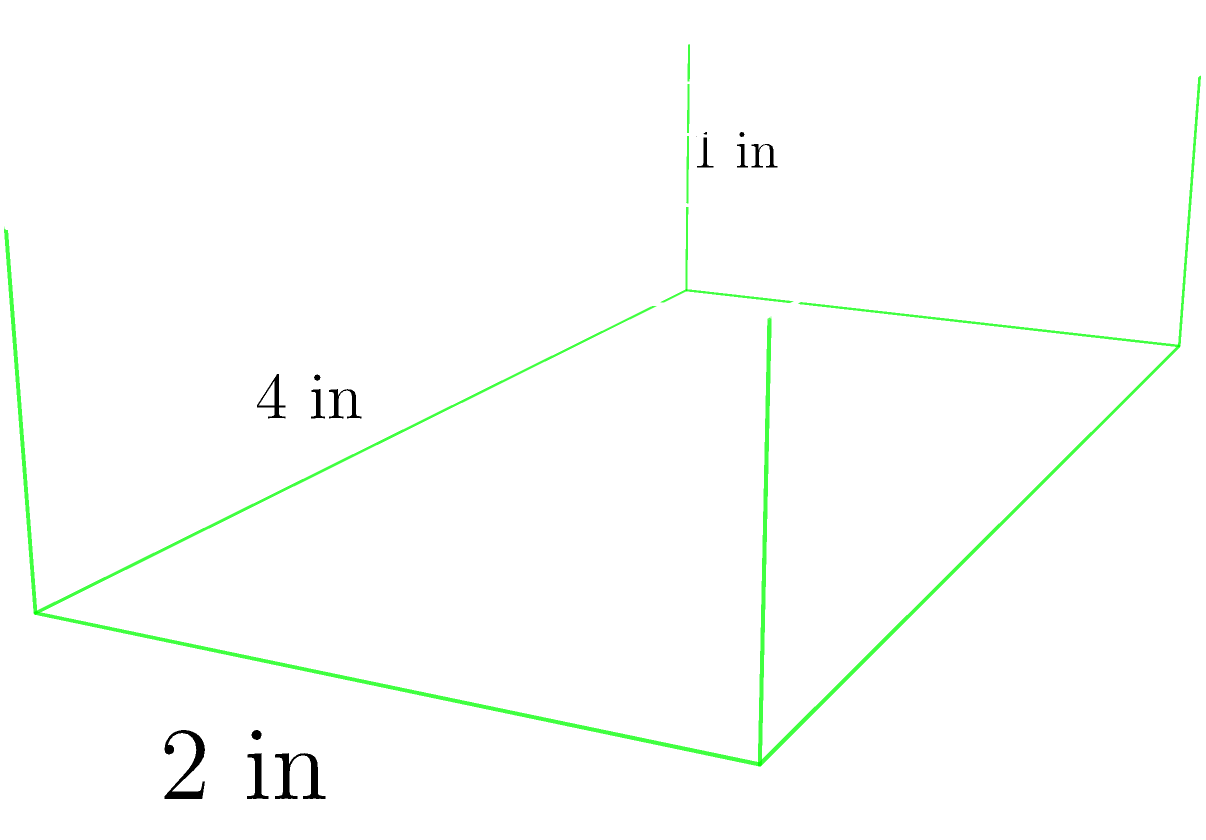A football-themed protein bar is shaped like a rectangular prism with dimensions 4 inches long, 2 inches wide, and 1 inch tall. The top surface is decorated with football field markings. Calculate the total surface area of this protein bar in square inches. Let's approach this step-by-step:

1) For a rectangular prism, we need to calculate the area of all six faces and sum them up.

2) The faces are:
   - Top and bottom: length × width (2 faces)
   - Front and back: length × height (2 faces)
   - Left and right: width × height (2 faces)

3) Let's calculate each:
   - Top/bottom: $4 \times 2 = 8$ sq in (each)
   - Front/back: $4 \times 1 = 4$ sq in (each)
   - Left/right: $2 \times 1 = 2$ sq in (each)

4) Now, let's sum up all the faces:
   $$(2 \times 8) + (2 \times 4) + (2 \times 2) = 16 + 8 + 4 = 28$$

5) Therefore, the total surface area is 28 square inches.

Note: The football field markings on the top surface don't affect the calculation of the surface area.
Answer: 28 sq in 